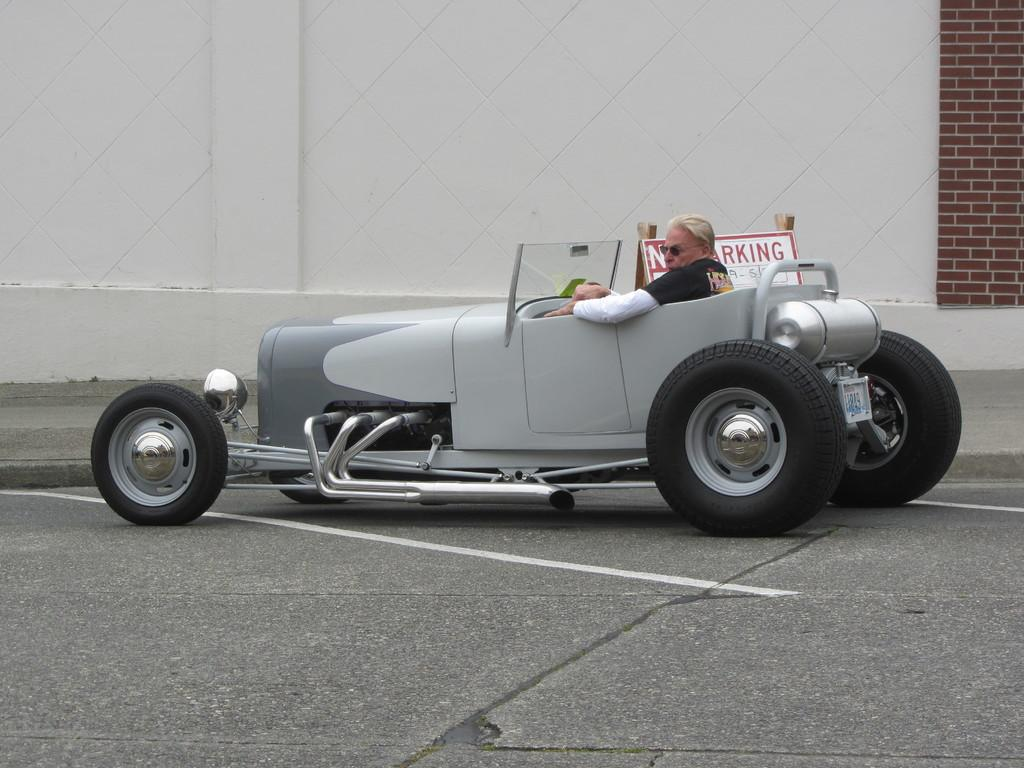What is the main subject of the image? There is a car on the road in the image. Can you describe the person in the car? A person is sitting in the car. What else can be seen beside the car? There is a board beside the car. What is visible in the background of the image? There is a wall in the background of the image. How many flies can be seen on the person's pocket in the image? There are no flies or pockets visible in the image. 